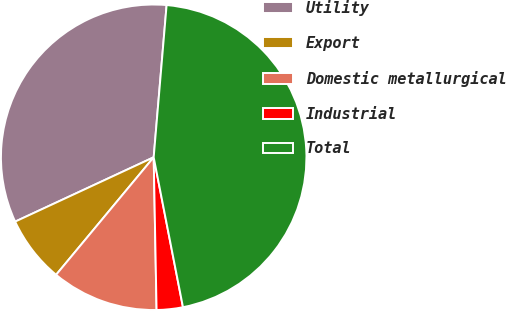Convert chart. <chart><loc_0><loc_0><loc_500><loc_500><pie_chart><fcel>Utility<fcel>Export<fcel>Domestic metallurgical<fcel>Industrial<fcel>Total<nl><fcel>33.27%<fcel>7.05%<fcel>11.33%<fcel>2.77%<fcel>45.58%<nl></chart> 